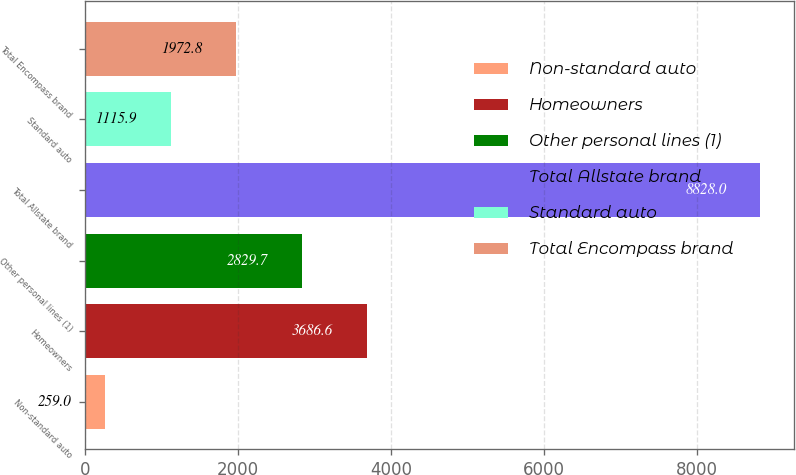Convert chart to OTSL. <chart><loc_0><loc_0><loc_500><loc_500><bar_chart><fcel>Non-standard auto<fcel>Homeowners<fcel>Other personal lines (1)<fcel>Total Allstate brand<fcel>Standard auto<fcel>Total Encompass brand<nl><fcel>259<fcel>3686.6<fcel>2829.7<fcel>8828<fcel>1115.9<fcel>1972.8<nl></chart> 